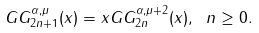<formula> <loc_0><loc_0><loc_500><loc_500>G G _ { 2 n + 1 } ^ { \alpha , \mu } ( x ) = x G G _ { 2 n } ^ { \alpha , \mu + 2 } ( x ) , \ n \geq 0 .</formula> 